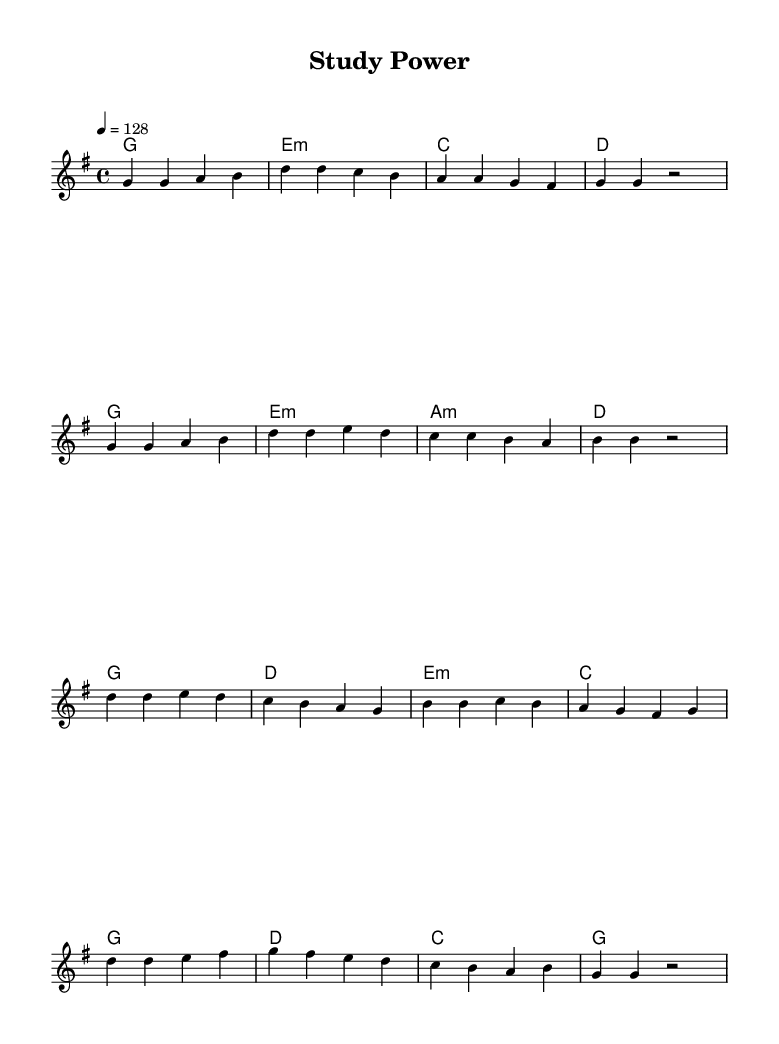What is the key signature of this music? The key signature is G major, which contains one sharp (F#). It can be identified by looking at the key signature at the beginning of the staff.
Answer: G major What is the time signature of the piece? The time signature is 4/4, which can be seen at the beginning of the staff and indicates that there are four beats per measure and the quarter note gets one beat.
Answer: 4/4 What is the tempo marking for this piece? The tempo marking indicates a speed of 128 beats per minute, as noted at the beginning with a "4 = 128". It shows how fast the music should be played.
Answer: 128 How many measures are in the verse? The verse consists of eight measures, which can be determined by counting the individual measures in the melody section labeled as the verse.
Answer: Eight What is the main theme expressed in the lyrics of the chorus? The lyrics of the chorus express determination and motivation to overcome academic challenges, highlighting themes of resilience and ambition. By analyzing the lyrics provided, it is clear that they convey a strong, uplifting message.
Answer: Determination Which chords are used in the chorus? The chords used in the chorus are G, D, E minor, and C. This can be seen in the chord progression written above the melody line in the section corresponding to the chorus.
Answer: G, D, E minor, C What is the lyrical structure of the verse? The lyrical structure of the verse consists of four lines (or phrases) that depict the stress of academic life but also emphasize a commitment to overcome these challenges. Each line reflects the gradual buildup of tension before resolving into a stronger conclusion.
Answer: Four lines 